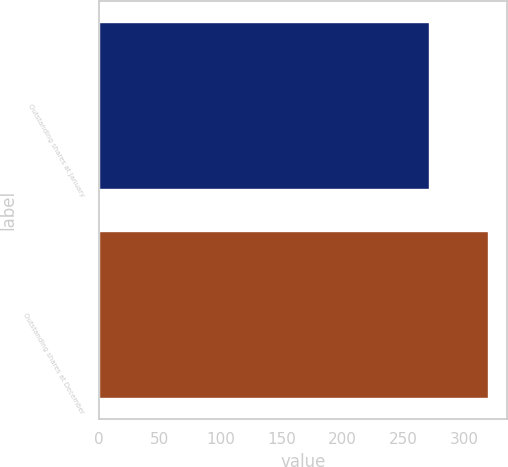Convert chart. <chart><loc_0><loc_0><loc_500><loc_500><bar_chart><fcel>Outstanding shares at January<fcel>Outstanding shares at December<nl><fcel>271.08<fcel>319<nl></chart> 